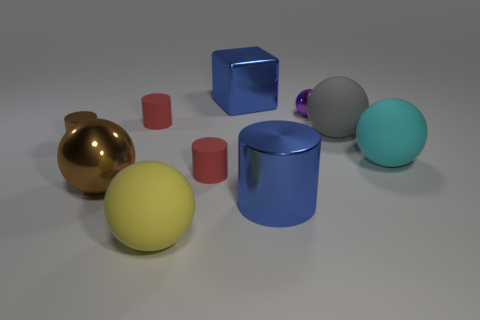Subtract all blue metal cylinders. How many cylinders are left? 3 Subtract all red balls. How many red cylinders are left? 2 Subtract all purple spheres. How many spheres are left? 4 Subtract 3 spheres. How many spheres are left? 2 Subtract all cylinders. How many objects are left? 6 Subtract all green balls. Subtract all red cubes. How many balls are left? 5 Subtract all tiny purple matte objects. Subtract all small cylinders. How many objects are left? 7 Add 4 large blue cubes. How many large blue cubes are left? 5 Add 7 big purple rubber things. How many big purple rubber things exist? 7 Subtract 0 gray cubes. How many objects are left? 10 